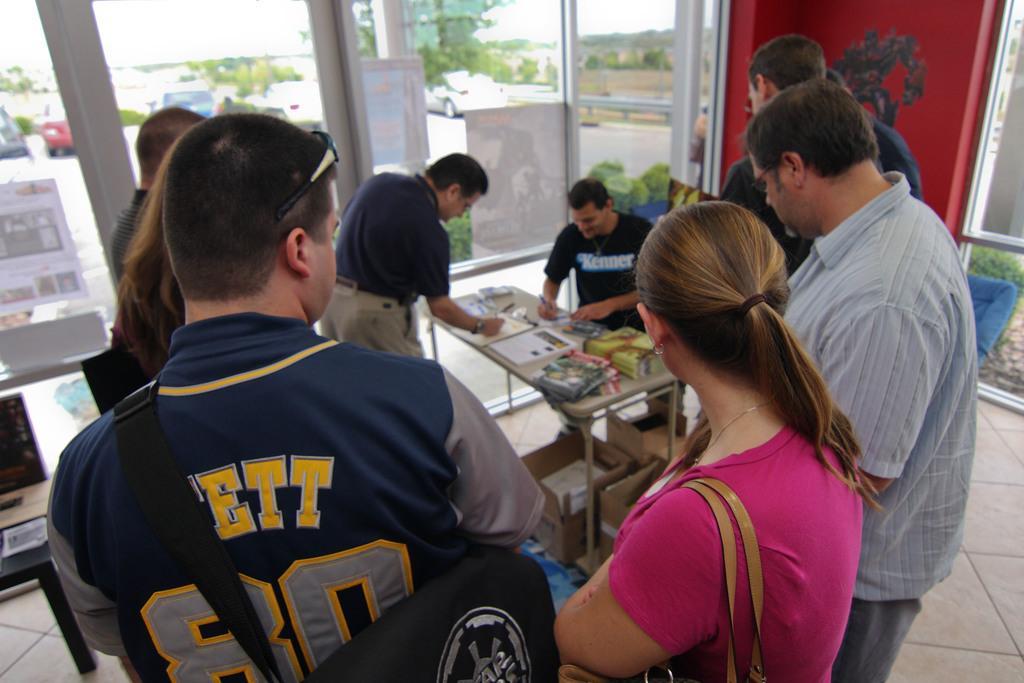Please provide a concise description of this image. In this image we can see people and there is a table. We can see things placed on the table. In the background there is a board and we can see cardboard boxes. We can see trees, cars and sky through the glass doors. 